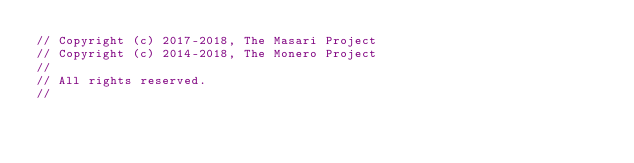<code> <loc_0><loc_0><loc_500><loc_500><_C++_>// Copyright (c) 2017-2018, The Masari Project
// Copyright (c) 2014-2018, The Monero Project
//
// All rights reserved.
//</code> 